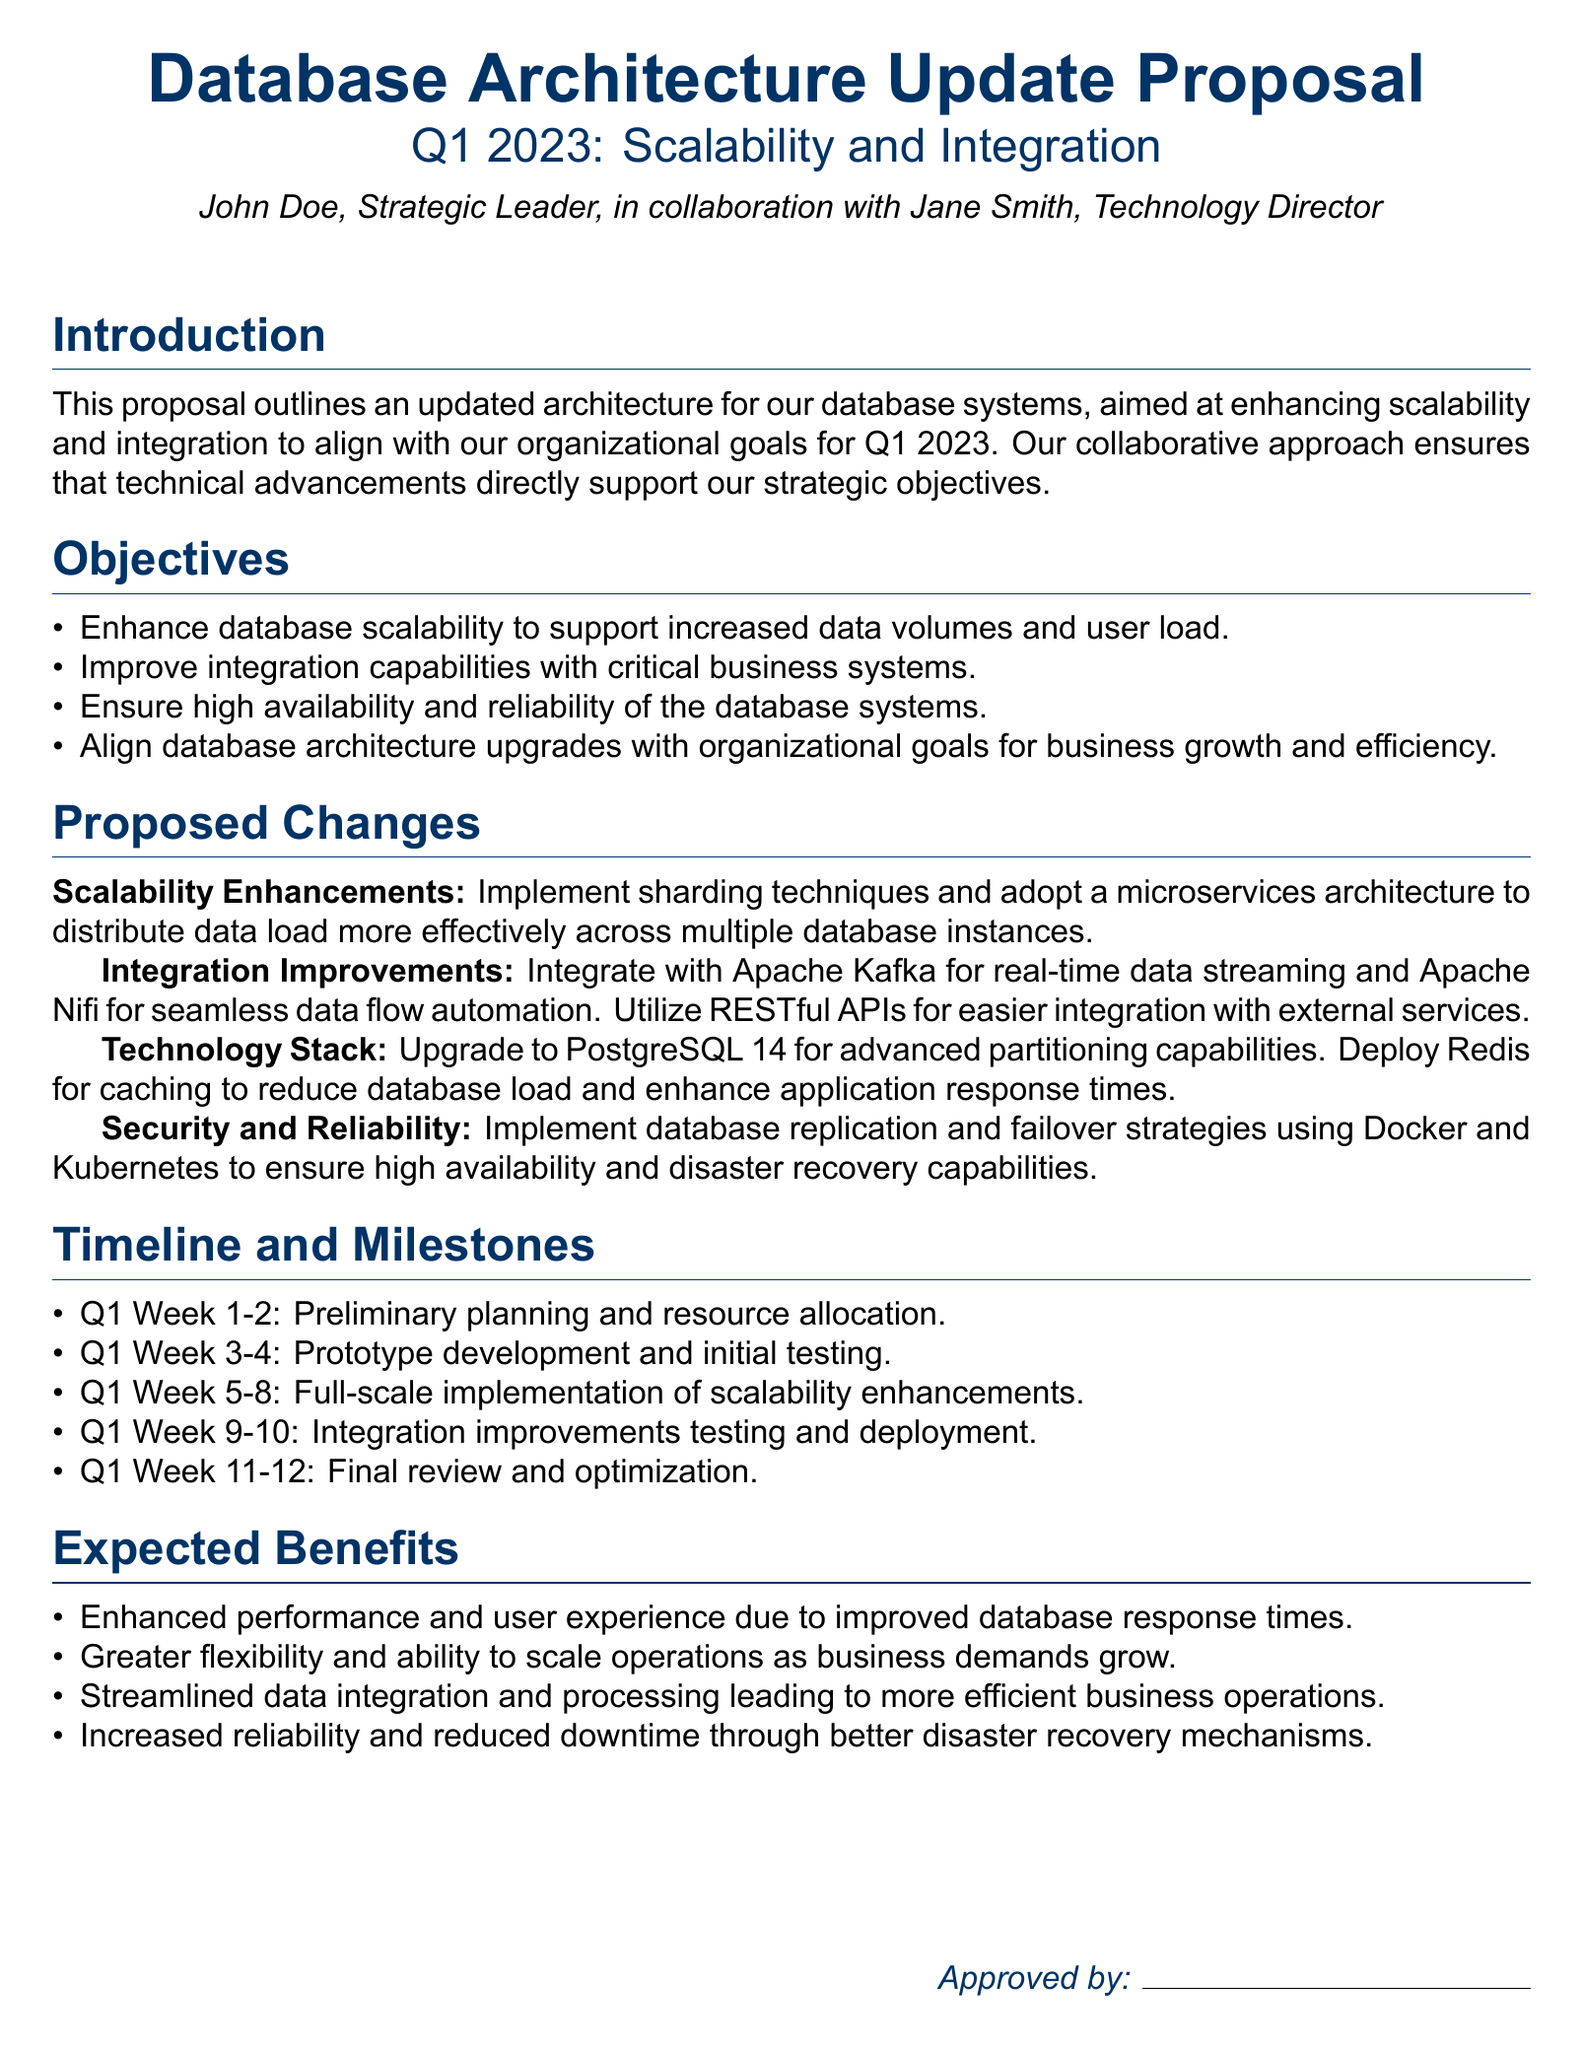What is the main focus of the proposal? The proposal outlines an updated architecture aimed at enhancing scalability and integration.
Answer: Scalability and integration Who collaborated with John Doe on this proposal? Jane Smith is mentioned as the Technology Director collaborating on the proposal.
Answer: Jane Smith What technology will be upgraded to version 14? The proposal specifies upgrading to PostgreSQL for advanced capabilities.
Answer: PostgreSQL What does the second proposed enhancement relate to? It mentions integrating with Apache Kafka for real-time data streaming.
Answer: Integration improvements How long is the initial planning phase scheduled to last? The initial planning phase is scheduled from Q1 Week 1-2, totaling two weeks.
Answer: Two weeks What is the goal for Q1 Week 11-12? The final review and optimization of the database architecture is scheduled for these weeks.
Answer: Final review and optimization Which caching technology is proposed in the document? The document proposes deploying Redis for caching benefits.
Answer: Redis What is the purpose of implementing database replication? It aims to ensure high availability and disaster recovery capabilities.
Answer: High availability and disaster recovery What are the expected benefits related to performance? The proposal highlights enhanced performance and user experience.
Answer: Enhanced performance and user experience 